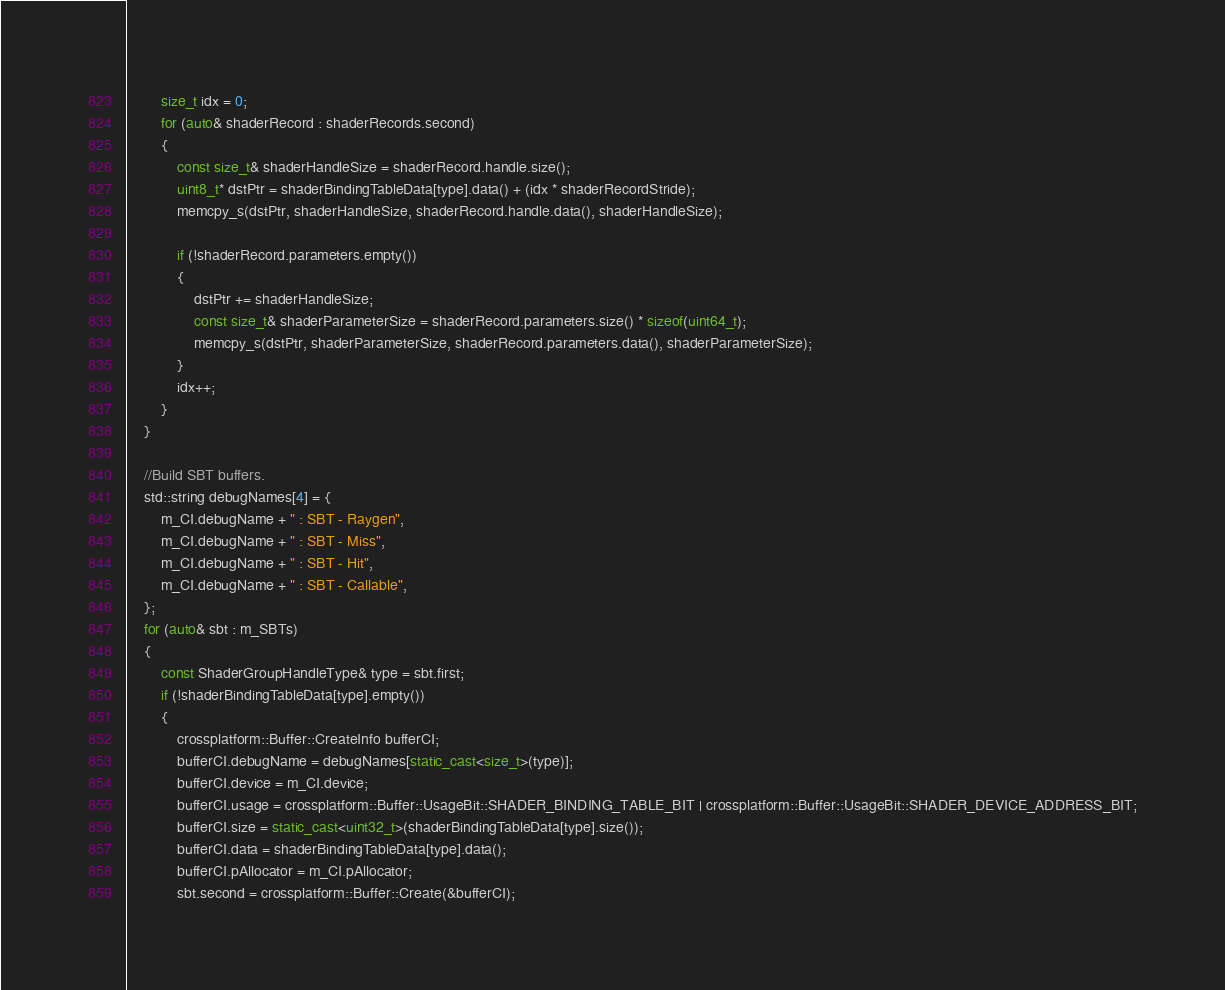<code> <loc_0><loc_0><loc_500><loc_500><_C++_>
		size_t idx = 0;
		for (auto& shaderRecord : shaderRecords.second)
		{
			const size_t& shaderHandleSize = shaderRecord.handle.size();
			uint8_t* dstPtr = shaderBindingTableData[type].data() + (idx * shaderRecordStride);
			memcpy_s(dstPtr, shaderHandleSize, shaderRecord.handle.data(), shaderHandleSize);

			if (!shaderRecord.parameters.empty())
			{
				dstPtr += shaderHandleSize;
				const size_t& shaderParameterSize = shaderRecord.parameters.size() * sizeof(uint64_t);
				memcpy_s(dstPtr, shaderParameterSize, shaderRecord.parameters.data(), shaderParameterSize);
			}
			idx++;
		}
	}

	//Build SBT buffers.
	std::string debugNames[4] = {
		m_CI.debugName + " : SBT - Raygen",
		m_CI.debugName + " : SBT - Miss",
		m_CI.debugName + " : SBT - Hit",
		m_CI.debugName + " : SBT - Callable",
	};
	for (auto& sbt : m_SBTs)
	{
		const ShaderGroupHandleType& type = sbt.first;
		if (!shaderBindingTableData[type].empty())
		{
			crossplatform::Buffer::CreateInfo bufferCI;
			bufferCI.debugName = debugNames[static_cast<size_t>(type)];
			bufferCI.device = m_CI.device;
			bufferCI.usage = crossplatform::Buffer::UsageBit::SHADER_BINDING_TABLE_BIT | crossplatform::Buffer::UsageBit::SHADER_DEVICE_ADDRESS_BIT;
			bufferCI.size = static_cast<uint32_t>(shaderBindingTableData[type].size());
			bufferCI.data = shaderBindingTableData[type].data();
			bufferCI.pAllocator = m_CI.pAllocator;
			sbt.second = crossplatform::Buffer::Create(&bufferCI);
</code> 